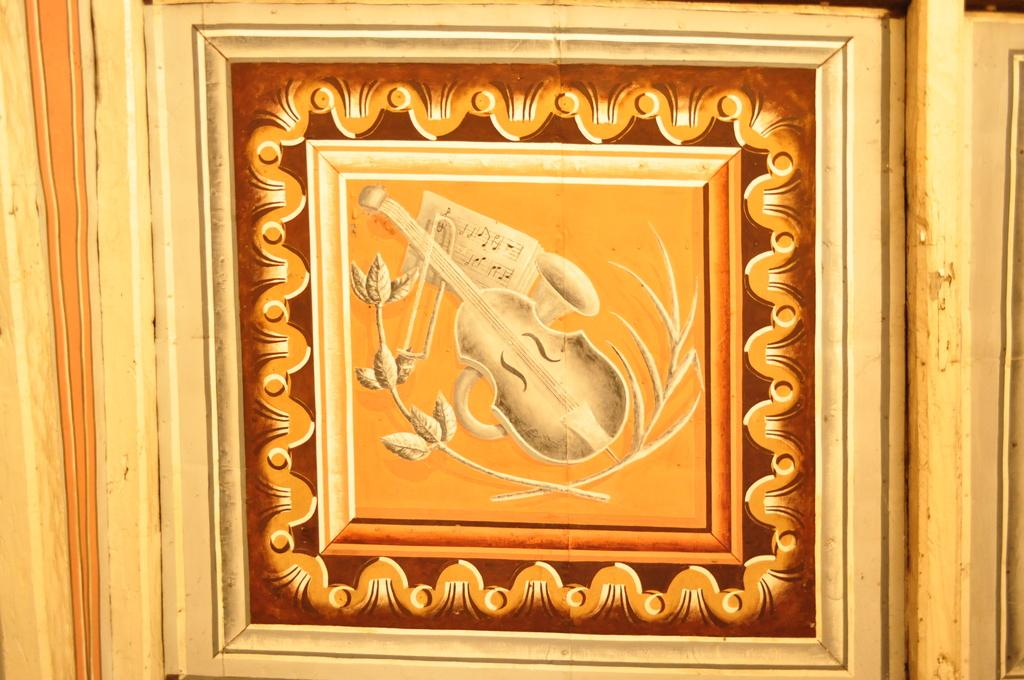What object in the image is used for creating music? There is a musical instrument in the image. What is the musical instrument resting on? The musical instrument is on a wooden object. What colors can be seen in the background of the image? The background of the image has brown and yellow colors. What type of thumb is visible in the image? There is no thumb present in the image. Is the image taken during the summer season? The provided facts do not mention any information about the season or weather, so it cannot be determined from the image. 